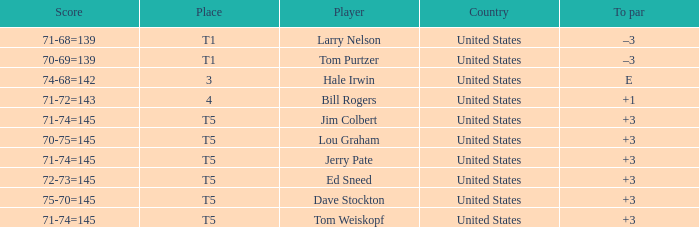Who is the player with a t5 place and a 75-70=145 score? Dave Stockton. 